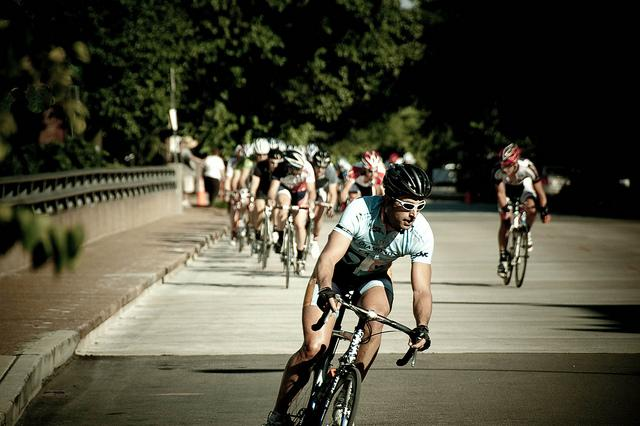What is the most likely reason the street is filled with bicyclists? Please explain your reasoning. race. There is a race that is happening. 